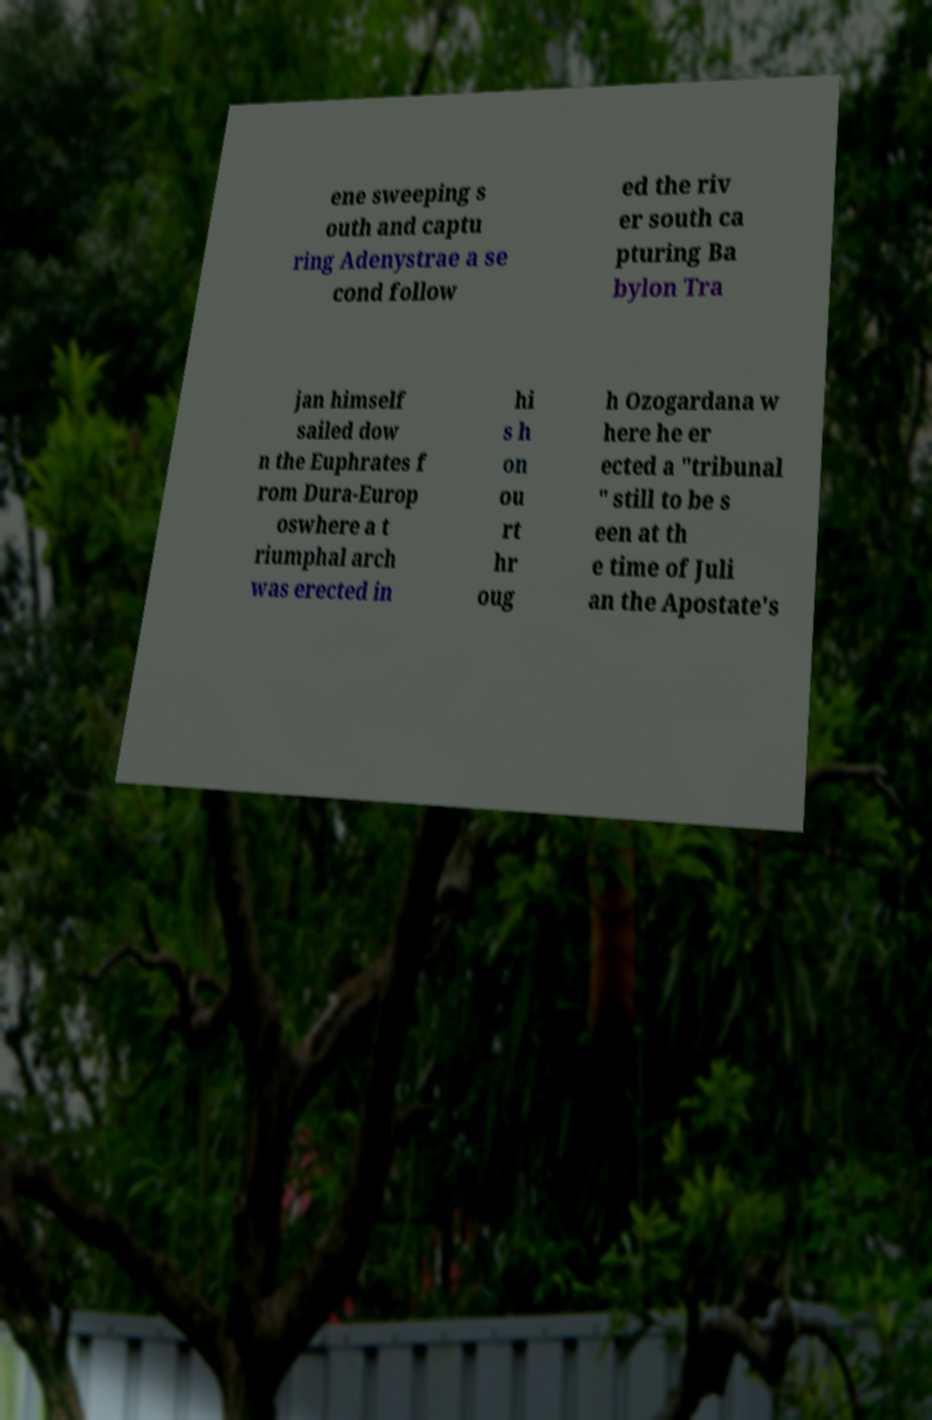I need the written content from this picture converted into text. Can you do that? ene sweeping s outh and captu ring Adenystrae a se cond follow ed the riv er south ca pturing Ba bylon Tra jan himself sailed dow n the Euphrates f rom Dura-Europ oswhere a t riumphal arch was erected in hi s h on ou rt hr oug h Ozogardana w here he er ected a "tribunal " still to be s een at th e time of Juli an the Apostate's 